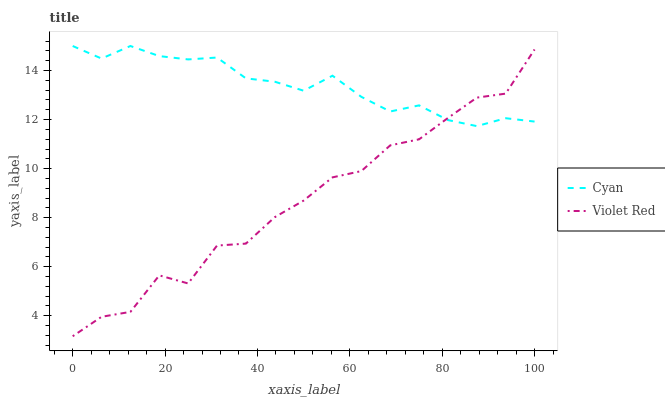Does Violet Red have the minimum area under the curve?
Answer yes or no. Yes. Does Cyan have the maximum area under the curve?
Answer yes or no. Yes. Does Violet Red have the maximum area under the curve?
Answer yes or no. No. Is Cyan the smoothest?
Answer yes or no. Yes. Is Violet Red the roughest?
Answer yes or no. Yes. Is Violet Red the smoothest?
Answer yes or no. No. Does Violet Red have the lowest value?
Answer yes or no. Yes. Does Cyan have the highest value?
Answer yes or no. Yes. Does Violet Red have the highest value?
Answer yes or no. No. Does Cyan intersect Violet Red?
Answer yes or no. Yes. Is Cyan less than Violet Red?
Answer yes or no. No. Is Cyan greater than Violet Red?
Answer yes or no. No. 